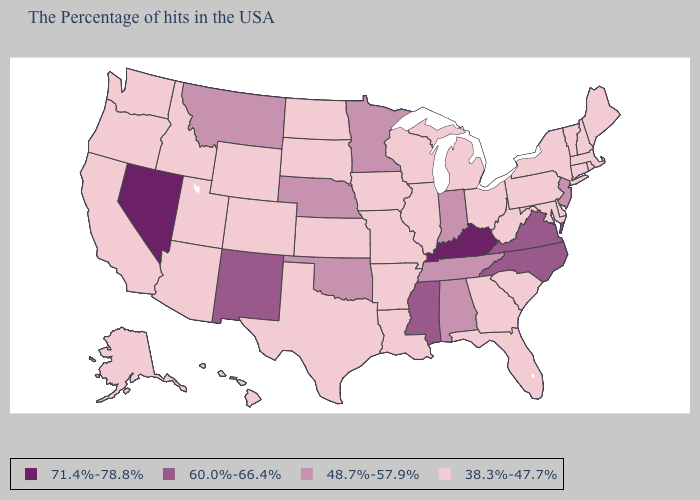Name the states that have a value in the range 60.0%-66.4%?
Give a very brief answer. Virginia, North Carolina, Mississippi, New Mexico. Name the states that have a value in the range 38.3%-47.7%?
Write a very short answer. Maine, Massachusetts, Rhode Island, New Hampshire, Vermont, Connecticut, New York, Delaware, Maryland, Pennsylvania, South Carolina, West Virginia, Ohio, Florida, Georgia, Michigan, Wisconsin, Illinois, Louisiana, Missouri, Arkansas, Iowa, Kansas, Texas, South Dakota, North Dakota, Wyoming, Colorado, Utah, Arizona, Idaho, California, Washington, Oregon, Alaska, Hawaii. What is the value of Rhode Island?
Keep it brief. 38.3%-47.7%. What is the value of California?
Keep it brief. 38.3%-47.7%. What is the highest value in the South ?
Answer briefly. 71.4%-78.8%. Which states have the highest value in the USA?
Short answer required. Kentucky, Nevada. Does Louisiana have the same value as Massachusetts?
Concise answer only. Yes. What is the value of North Dakota?
Quick response, please. 38.3%-47.7%. Name the states that have a value in the range 48.7%-57.9%?
Short answer required. New Jersey, Indiana, Alabama, Tennessee, Minnesota, Nebraska, Oklahoma, Montana. Which states have the highest value in the USA?
Keep it brief. Kentucky, Nevada. Among the states that border Idaho , which have the lowest value?
Answer briefly. Wyoming, Utah, Washington, Oregon. What is the value of Minnesota?
Concise answer only. 48.7%-57.9%. Name the states that have a value in the range 48.7%-57.9%?
Be succinct. New Jersey, Indiana, Alabama, Tennessee, Minnesota, Nebraska, Oklahoma, Montana. What is the value of Louisiana?
Keep it brief. 38.3%-47.7%. Does Ohio have the lowest value in the USA?
Quick response, please. Yes. 